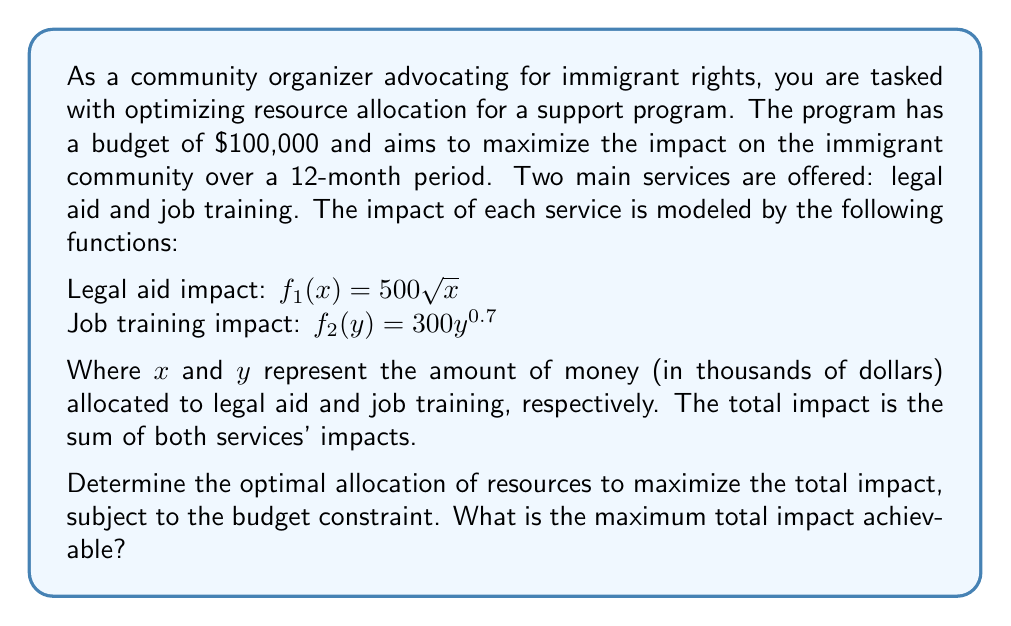Help me with this question. To solve this optimal control problem, we'll use the method of Lagrange multipliers:

1) Define the objective function:
   $J(x,y) = f_1(x) + f_2(y) = 500\sqrt{x} + 300y^{0.7}$

2) Define the constraint:
   $g(x,y) = x + y - 100 = 0$ (budget constraint in thousands of dollars)

3) Form the Lagrangian:
   $L(x,y,\lambda) = 500\sqrt{x} + 300y^{0.7} + \lambda(100 - x - y)$

4) Set partial derivatives to zero:
   $$\frac{\partial L}{\partial x} = \frac{250}{\sqrt{x}} - \lambda = 0$$
   $$\frac{\partial L}{\partial y} = 210y^{-0.3} - \lambda = 0$$
   $$\frac{\partial L}{\partial \lambda} = 100 - x - y = 0$$

5) From the first two equations:
   $$\frac{250}{\sqrt{x}} = 210y^{-0.3}$$

6) Rearranging:
   $$y = \left(\frac{210\sqrt{x}}{250}\right)^{10/3}$$

7) Substitute into the constraint:
   $$x + \left(\frac{210\sqrt{x}}{250}\right)^{10/3} = 100$$

8) Solve this equation numerically (e.g., using Newton's method) to get:
   $x \approx 61.54$ thousand dollars

9) Then:
   $y \approx 38.46$ thousand dollars

10) Calculate the total impact:
    $J(61.54, 38.46) = 500\sqrt{61.54} + 300(38.46)^{0.7} \approx 5,414.7$
Answer: The optimal allocation is approximately $61,540 for legal aid and $38,460 for job training. The maximum total impact achievable is approximately 5,414.7 units. 